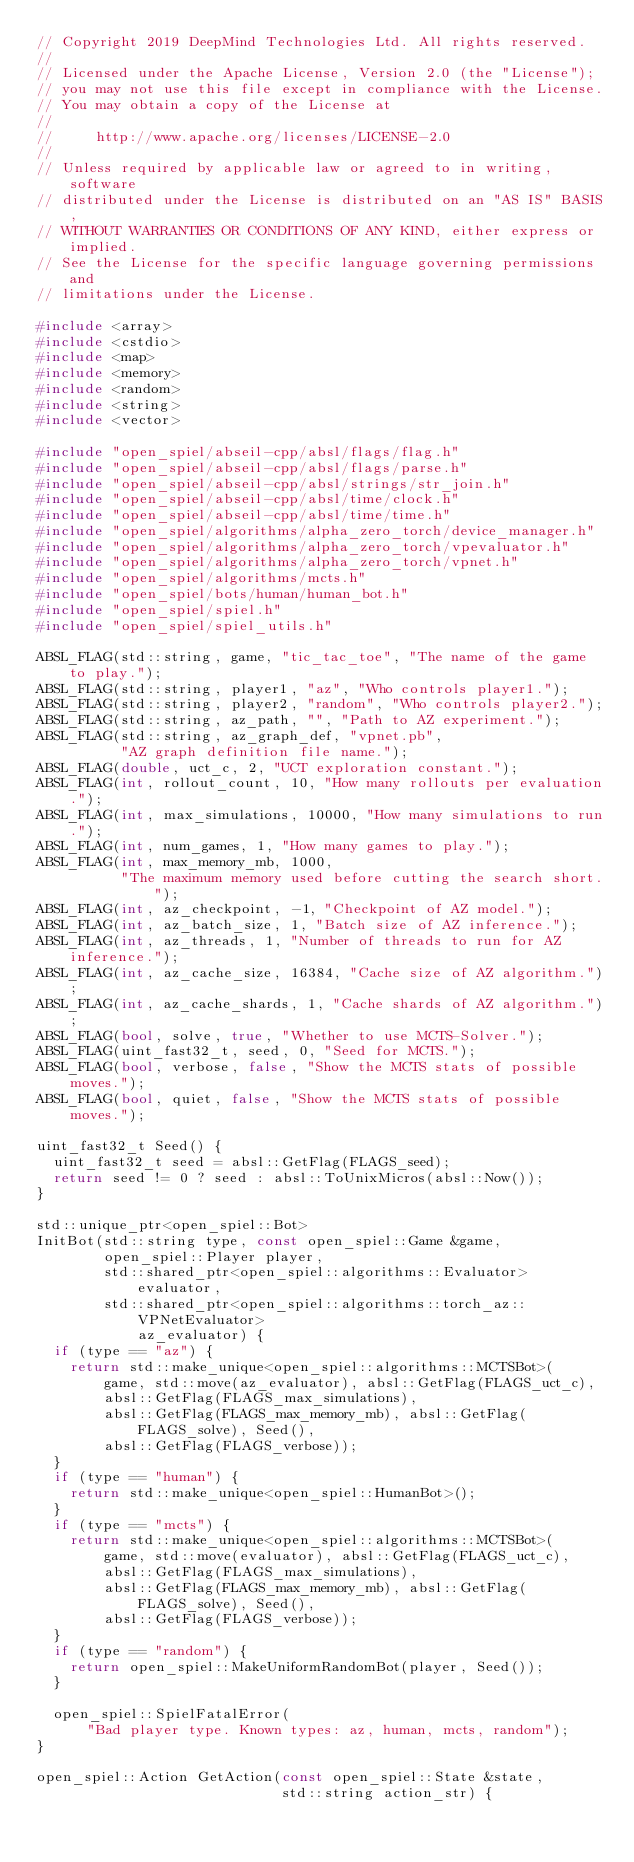<code> <loc_0><loc_0><loc_500><loc_500><_C++_>// Copyright 2019 DeepMind Technologies Ltd. All rights reserved.
//
// Licensed under the Apache License, Version 2.0 (the "License");
// you may not use this file except in compliance with the License.
// You may obtain a copy of the License at
//
//     http://www.apache.org/licenses/LICENSE-2.0
//
// Unless required by applicable law or agreed to in writing, software
// distributed under the License is distributed on an "AS IS" BASIS,
// WITHOUT WARRANTIES OR CONDITIONS OF ANY KIND, either express or implied.
// See the License for the specific language governing permissions and
// limitations under the License.

#include <array>
#include <cstdio>
#include <map>
#include <memory>
#include <random>
#include <string>
#include <vector>

#include "open_spiel/abseil-cpp/absl/flags/flag.h"
#include "open_spiel/abseil-cpp/absl/flags/parse.h"
#include "open_spiel/abseil-cpp/absl/strings/str_join.h"
#include "open_spiel/abseil-cpp/absl/time/clock.h"
#include "open_spiel/abseil-cpp/absl/time/time.h"
#include "open_spiel/algorithms/alpha_zero_torch/device_manager.h"
#include "open_spiel/algorithms/alpha_zero_torch/vpevaluator.h"
#include "open_spiel/algorithms/alpha_zero_torch/vpnet.h"
#include "open_spiel/algorithms/mcts.h"
#include "open_spiel/bots/human/human_bot.h"
#include "open_spiel/spiel.h"
#include "open_spiel/spiel_utils.h"

ABSL_FLAG(std::string, game, "tic_tac_toe", "The name of the game to play.");
ABSL_FLAG(std::string, player1, "az", "Who controls player1.");
ABSL_FLAG(std::string, player2, "random", "Who controls player2.");
ABSL_FLAG(std::string, az_path, "", "Path to AZ experiment.");
ABSL_FLAG(std::string, az_graph_def, "vpnet.pb",
          "AZ graph definition file name.");
ABSL_FLAG(double, uct_c, 2, "UCT exploration constant.");
ABSL_FLAG(int, rollout_count, 10, "How many rollouts per evaluation.");
ABSL_FLAG(int, max_simulations, 10000, "How many simulations to run.");
ABSL_FLAG(int, num_games, 1, "How many games to play.");
ABSL_FLAG(int, max_memory_mb, 1000,
          "The maximum memory used before cutting the search short.");
ABSL_FLAG(int, az_checkpoint, -1, "Checkpoint of AZ model.");
ABSL_FLAG(int, az_batch_size, 1, "Batch size of AZ inference.");
ABSL_FLAG(int, az_threads, 1, "Number of threads to run for AZ inference.");
ABSL_FLAG(int, az_cache_size, 16384, "Cache size of AZ algorithm.");
ABSL_FLAG(int, az_cache_shards, 1, "Cache shards of AZ algorithm.");
ABSL_FLAG(bool, solve, true, "Whether to use MCTS-Solver.");
ABSL_FLAG(uint_fast32_t, seed, 0, "Seed for MCTS.");
ABSL_FLAG(bool, verbose, false, "Show the MCTS stats of possible moves.");
ABSL_FLAG(bool, quiet, false, "Show the MCTS stats of possible moves.");

uint_fast32_t Seed() {
  uint_fast32_t seed = absl::GetFlag(FLAGS_seed);
  return seed != 0 ? seed : absl::ToUnixMicros(absl::Now());
}

std::unique_ptr<open_spiel::Bot>
InitBot(std::string type, const open_spiel::Game &game,
        open_spiel::Player player,
        std::shared_ptr<open_spiel::algorithms::Evaluator> evaluator,
        std::shared_ptr<open_spiel::algorithms::torch_az::VPNetEvaluator>
            az_evaluator) {
  if (type == "az") {
    return std::make_unique<open_spiel::algorithms::MCTSBot>(
        game, std::move(az_evaluator), absl::GetFlag(FLAGS_uct_c),
        absl::GetFlag(FLAGS_max_simulations),
        absl::GetFlag(FLAGS_max_memory_mb), absl::GetFlag(FLAGS_solve), Seed(),
        absl::GetFlag(FLAGS_verbose));
  }
  if (type == "human") {
    return std::make_unique<open_spiel::HumanBot>();
  }
  if (type == "mcts") {
    return std::make_unique<open_spiel::algorithms::MCTSBot>(
        game, std::move(evaluator), absl::GetFlag(FLAGS_uct_c),
        absl::GetFlag(FLAGS_max_simulations),
        absl::GetFlag(FLAGS_max_memory_mb), absl::GetFlag(FLAGS_solve), Seed(),
        absl::GetFlag(FLAGS_verbose));
  }
  if (type == "random") {
    return open_spiel::MakeUniformRandomBot(player, Seed());
  }

  open_spiel::SpielFatalError(
      "Bad player type. Known types: az, human, mcts, random");
}

open_spiel::Action GetAction(const open_spiel::State &state,
                             std::string action_str) {</code> 